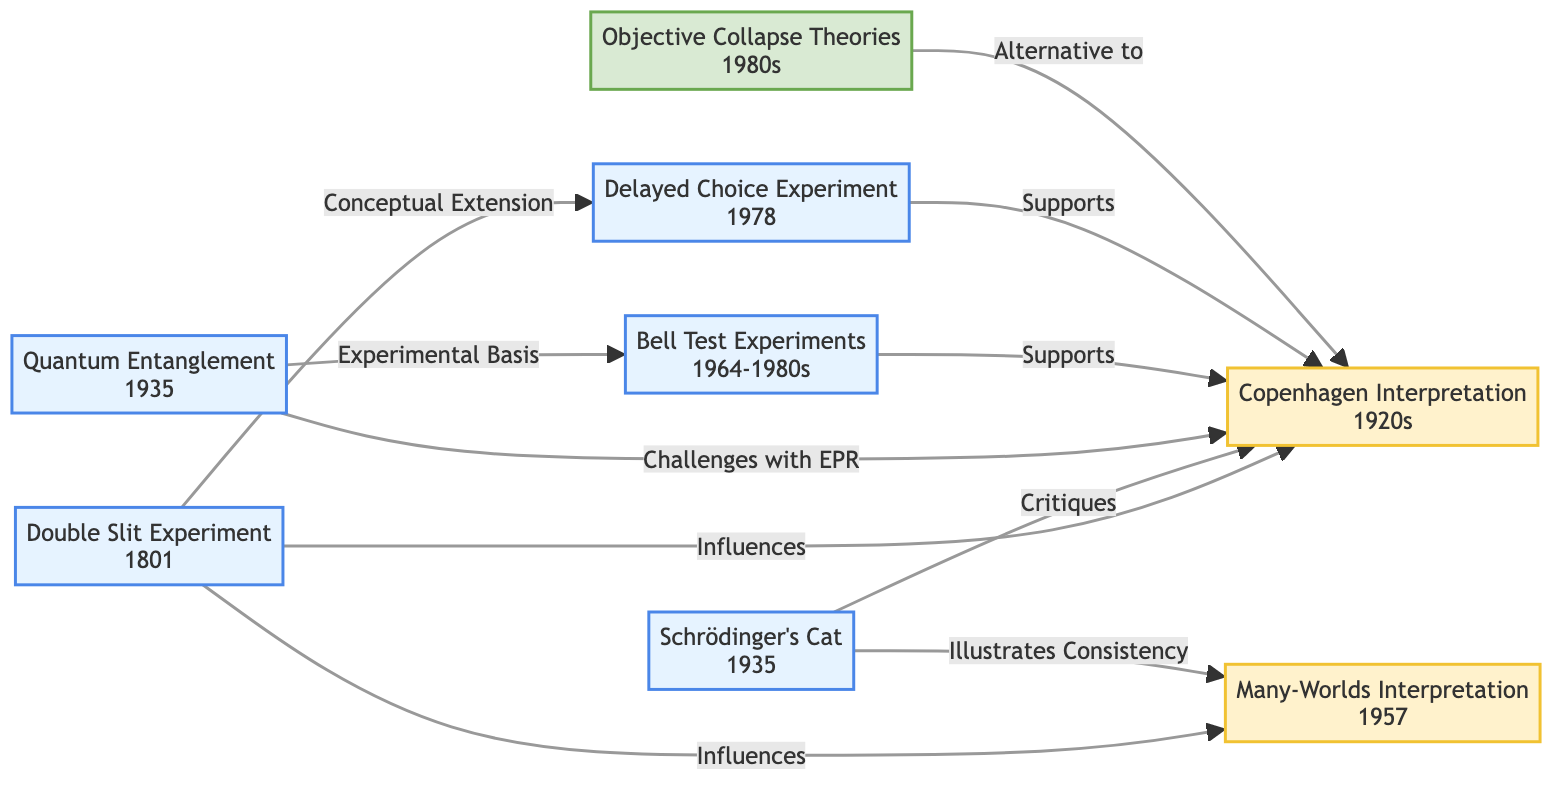What experimental event was conducted first in the timeline? The diagram indicates that the Double Slit Experiment occurred in 1801, making it the earliest event listed.
Answer: Double Slit Experiment Which interpretation of quantum mechanics emerged in the 1920s? The diagram shows that the Copenhagen Interpretation developed during the 1920s, as indicated by its label.
Answer: Copenhagen Interpretation How many key experiments support the Copenhagen Interpretation? Based on the diagram, three key experiments are connected to the Copenhagen Interpretation: Bell Test Experiments, Delayed Choice Experiment, and Double Slit Experiment.
Answer: Three What theory is presented as an alternative to the Copenhagen Interpretation? The diagram illustrates that Objective Collapse Theories are presented as an alternative to the Copenhagen Interpretation.
Answer: Objective Collapse Theories What does the Schrödinger's Cat experiment critique? According to the diagram, Schrödinger's Cat critiques the Copenhagen Interpretation as indicated by the directional arrow labeling "Critiques".
Answer: Copenhagen Interpretation Which experiment illustrates consistency with Many-Worlds Interpretation? The diagram states that Schrödinger's Cat illustrates consistency with the Many-Worlds Interpretation. This relationship is shown by the connecting arrow labeled "Illustrates Consistency".
Answer: Schrödinger's Cat How does Quantum Entanglement relate to the Copenhagen Interpretation? Quantum Entanglement challenges the Copenhagen Interpretation, which is evidenced by the arrow labeled "Challenges with EPR" connecting them.
Answer: Challenges with EPR What is the relationship between the Double Slit Experiment and the Delayed Choice Experiment? The diagram indicates that the Double Slit Experiment conceptually extends into the Delayed Choice Experiment. This means insights gained from the Double Slit Experiment influenced the development of the Delayed Choice Experiment.
Answer: Conceptual Extension What years do the Bell Test Experiments span? The diagram specifies the years 1964 to 1980s, indicating the timeframe during which the Bell Test Experiments were conducted.
Answer: 1964-1980s 